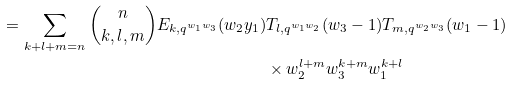Convert formula to latex. <formula><loc_0><loc_0><loc_500><loc_500>= \sum _ { k + l + m = n } \binom { n } { k , l , m } E _ { k , q ^ { w _ { 1 } w _ { 3 } } } ( w _ { 2 } y _ { 1 } ) & T _ { l , q ^ { w _ { 1 } w _ { 2 } } } ( w _ { 3 } - 1 ) T _ { m , q ^ { w _ { 2 } w _ { 3 } } } ( w _ { 1 } - 1 ) \\ & \times w _ { 2 } ^ { l + m } w _ { 3 } ^ { k + m } w _ { 1 } ^ { k + l }</formula> 